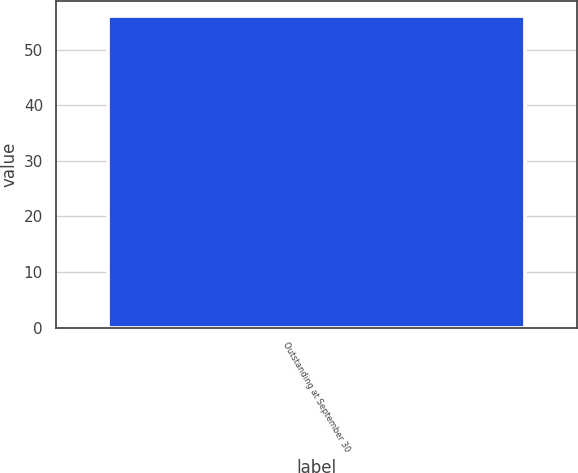<chart> <loc_0><loc_0><loc_500><loc_500><bar_chart><fcel>Outstanding at September 30<nl><fcel>56.03<nl></chart> 